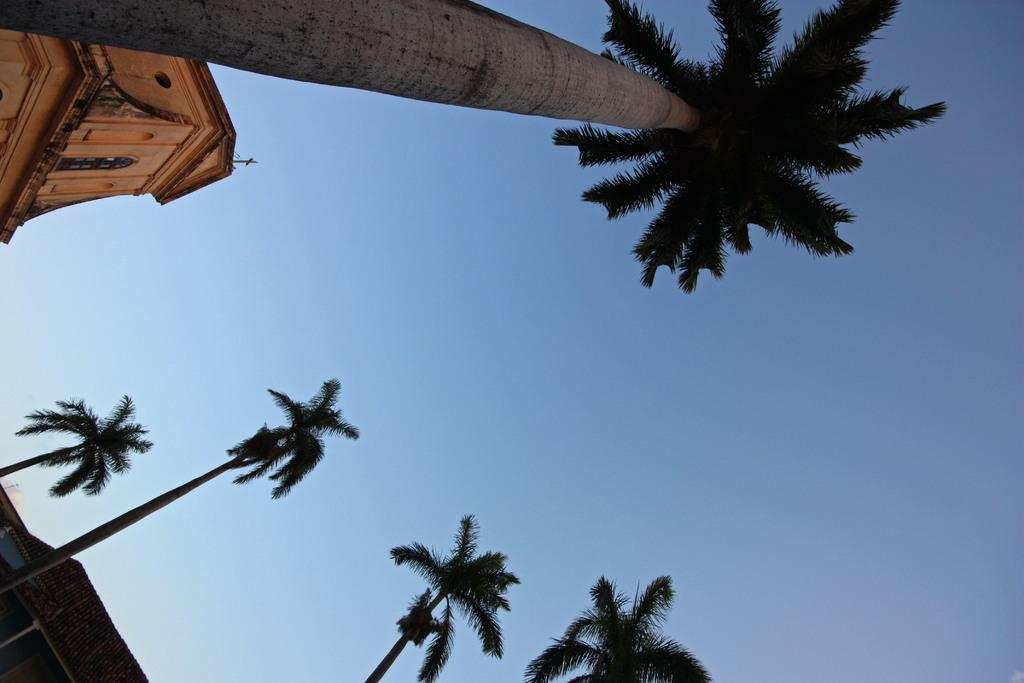What type of vegetation can be seen in the image? There are trees in the image. What type of building is present in the image? There is a church in the image. What color is the sky in the image? The sky is blue in the image. How does the love between the two people in the image manifest itself? There are no people present in the image, and therefore no love between them can be observed. 